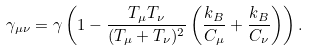<formula> <loc_0><loc_0><loc_500><loc_500>\gamma _ { \mu \nu } = \gamma \left ( 1 - \frac { T _ { \mu } T _ { \nu } } { ( T _ { \mu } + T _ { \nu } ) ^ { 2 } } \left ( \frac { k _ { B } } { C _ { \mu } } + \frac { k _ { B } } { C _ { \nu } } \right ) \right ) .</formula> 